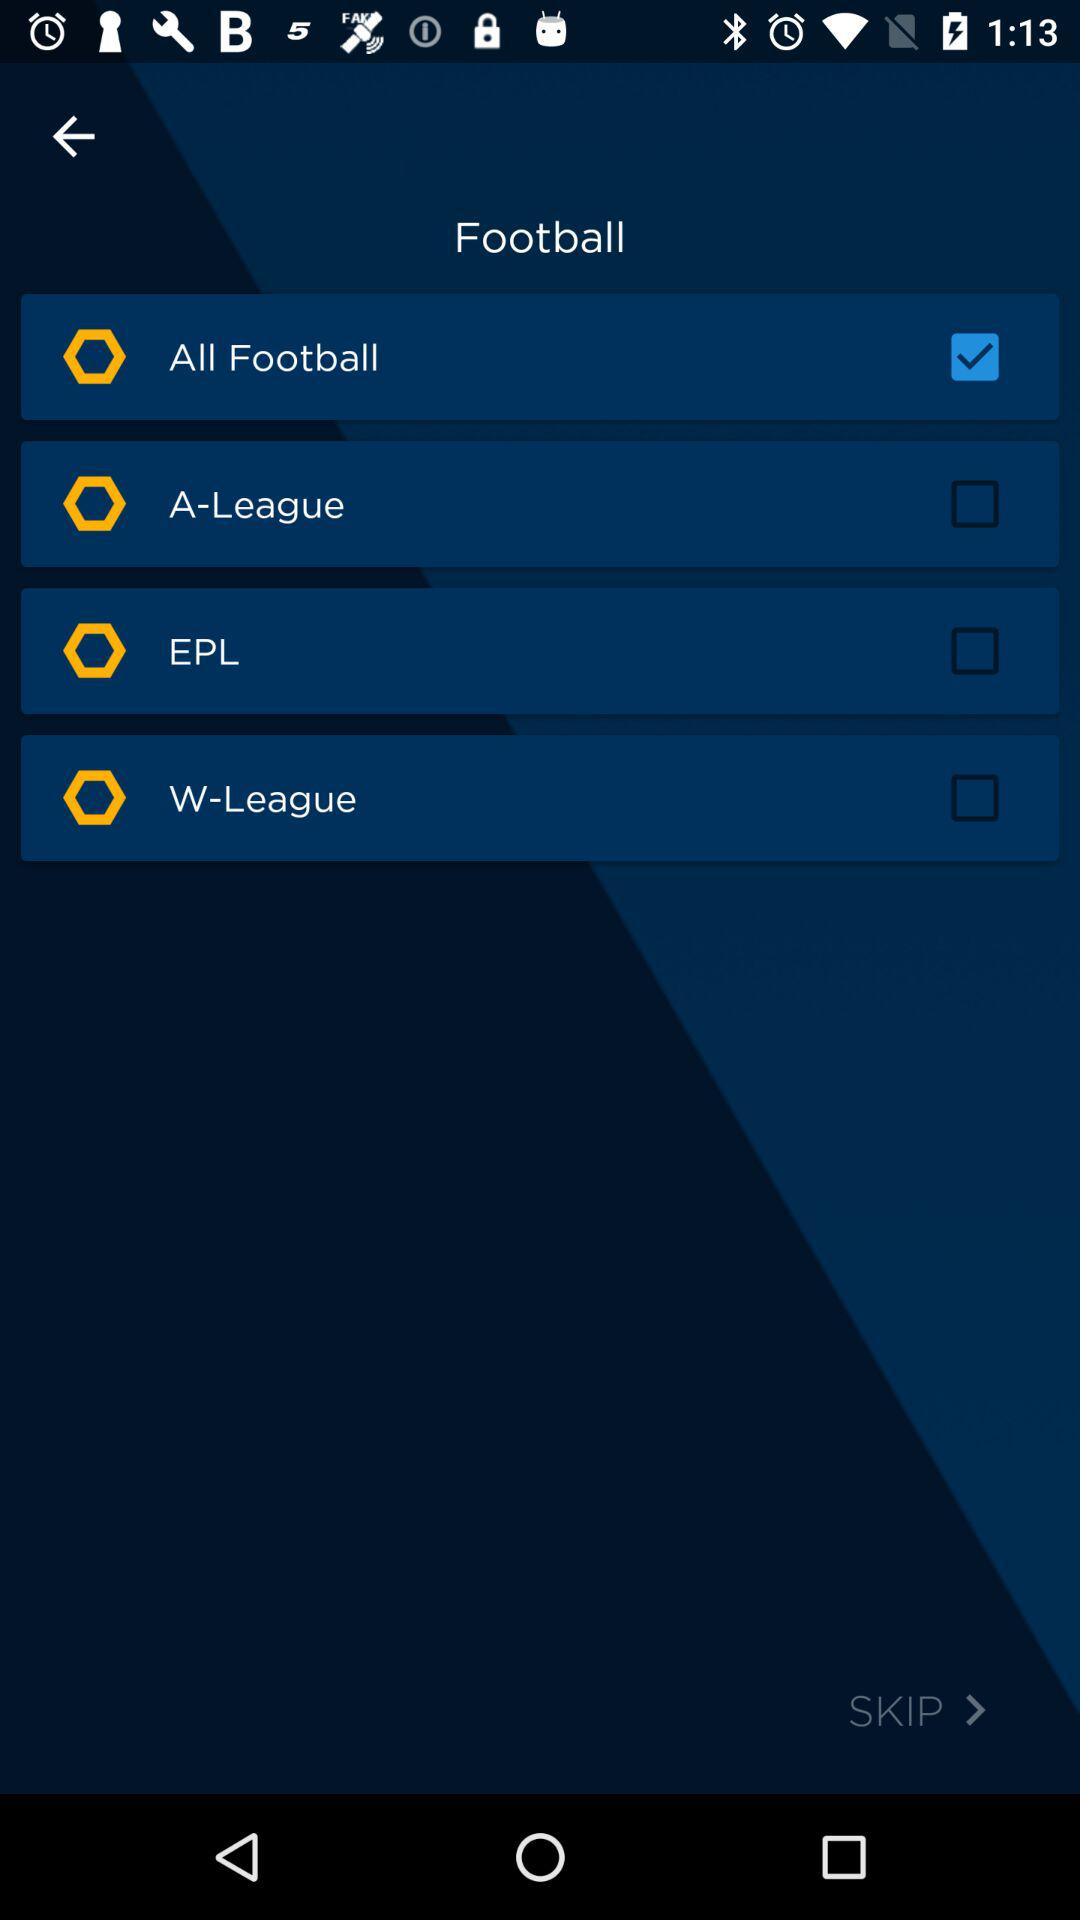How many football leagues are available to select?
Answer the question using a single word or phrase. 4 